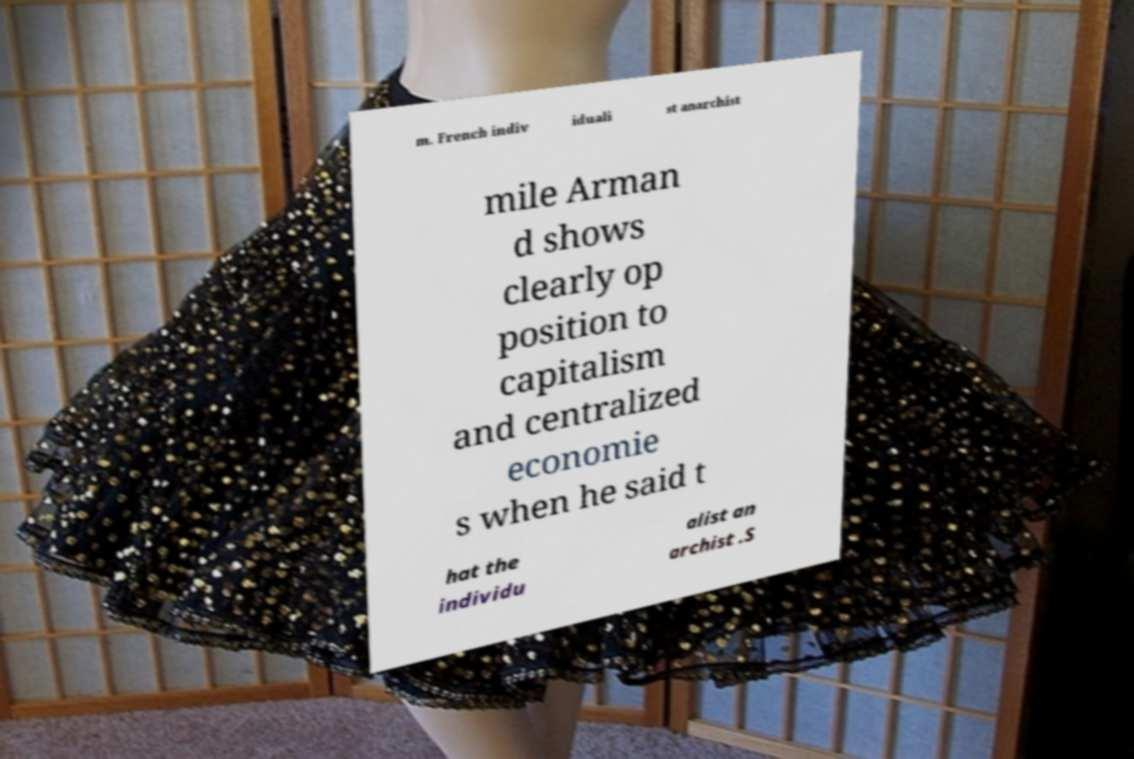Can you accurately transcribe the text from the provided image for me? m. French indiv iduali st anarchist mile Arman d shows clearly op position to capitalism and centralized economie s when he said t hat the individu alist an archist .S 